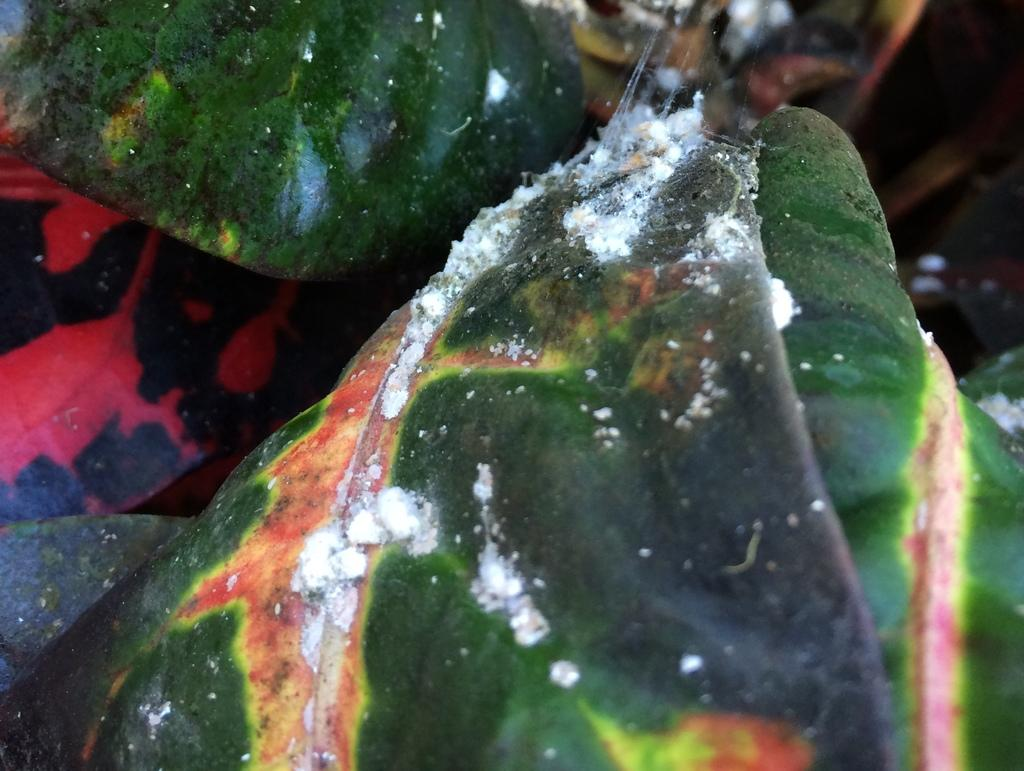What type of growth can be seen on the leaves in the foreground of the image? There is fungus on the leaves in the foreground of the image. What type of insurance policy is being discussed in the image? There is no discussion of insurance in the image; it features fungus on leaves. What type of building can be seen in the background of the image? There is no building present in the image; it only shows fungus on leaves in the foreground. 